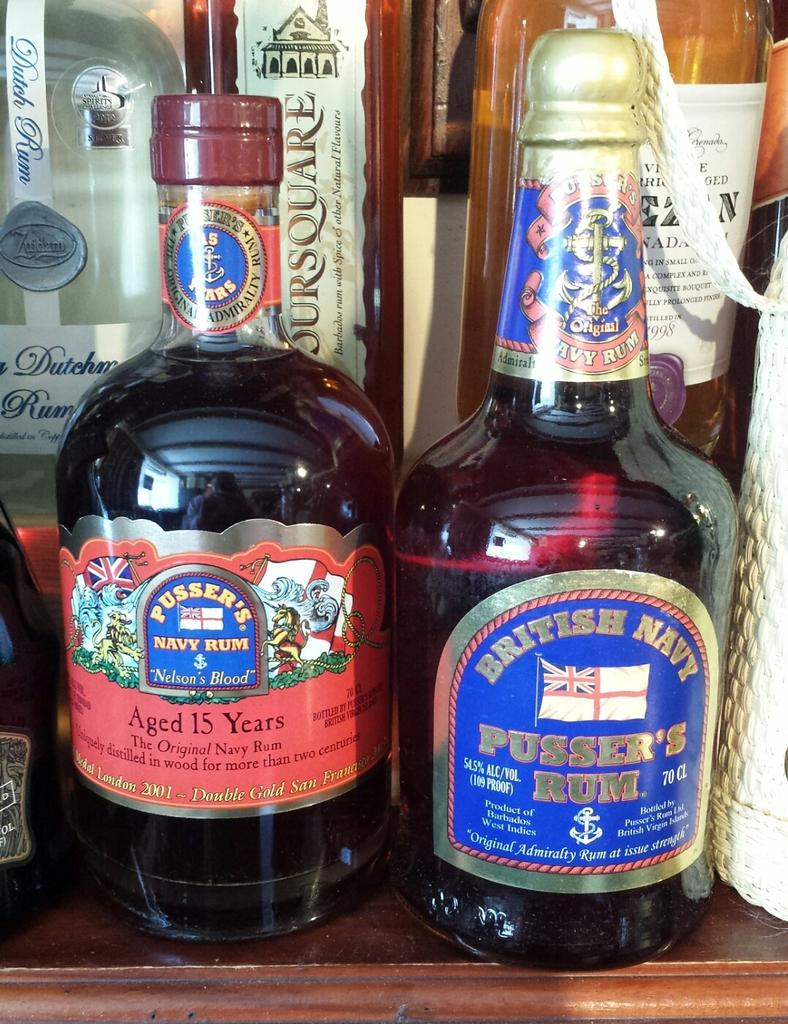<image>
Write a terse but informative summary of the picture. Two rum bottles, Pusser's and British Navy, wait on a shelf together. 